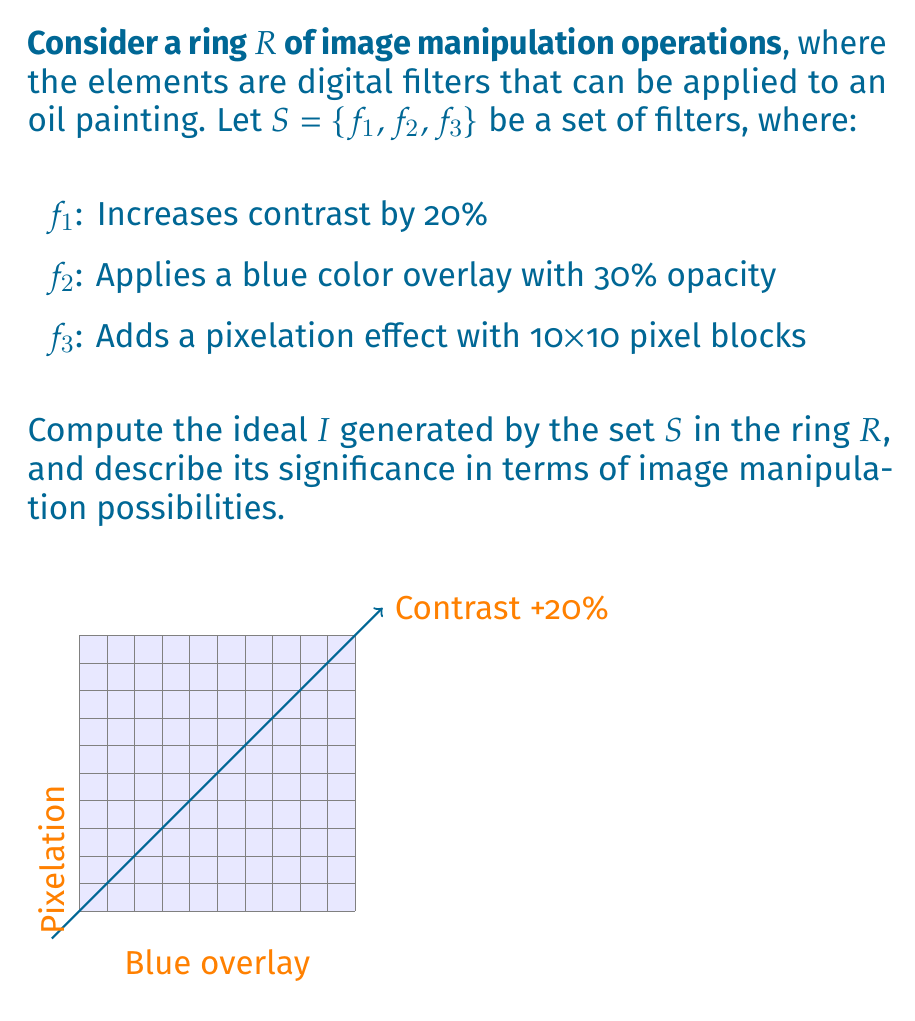Teach me how to tackle this problem. To compute the ideal generated by the set $S$ in the ring $R$, we need to consider all possible combinations and compositions of the given filters, as well as their interactions with other elements in the ring. Let's break this down step-by-step:

1) First, recall that an ideal $I$ in a ring $R$ is a subset of $R$ that satisfies the following properties:
   a) $I$ is closed under addition
   b) For any $r \in R$ and $i \in I$, both $ri$ and $ir$ are in $I$

2) The ideal generated by $S$, denoted $\langle S \rangle$ or $\langle f_1, f_2, f_3 \rangle$, is the smallest ideal containing $S$.

3) Elements in $\langle S \rangle$ will include:
   a) All individual filters: $f_1$, $f_2$, $f_3$
   b) All possible compositions of these filters in any order and any number of times: $f_1 \circ f_2$, $f_2 \circ f_3$, $f_1 \circ f_2 \circ f_3$, $f_1 \circ f_1$, etc.
   c) All linear combinations of these compositions with coefficients from $R$

4) Mathematically, we can express this as:

   $$\langle S \rangle = \left\{\sum_{i=1}^n r_i \circ (f_{j_1} \circ f_{j_2} \circ ... \circ f_{j_k}) : n,k \in \mathbb{N}, r_i \in R, f_{j_m} \in S\right\}$$

5) In terms of image manipulation, this ideal represents all possible image transformations that can be achieved by applying the given filters (contrast increase, blue overlay, pixelation) in any combination, order, and intensity.

6) The significance of this ideal in image manipulation:
   a) It defines the space of all possible image transformations using the given filters.
   b) Any image manipulation within this ideal can be achieved using only the basic filters $f_1$, $f_2$, and $f_3$.
   c) It allows for complex effects by combining simple filters, which is particularly relevant for digital art inspired oil paintings.
Answer: $\langle S \rangle = \left\{\sum_{i=1}^n r_i \circ (f_{j_1} \circ f_{j_2} \circ ... \circ f_{j_k}) : n,k \in \mathbb{N}, r_i \in R, f_{j_m} \in S\right\}$ 